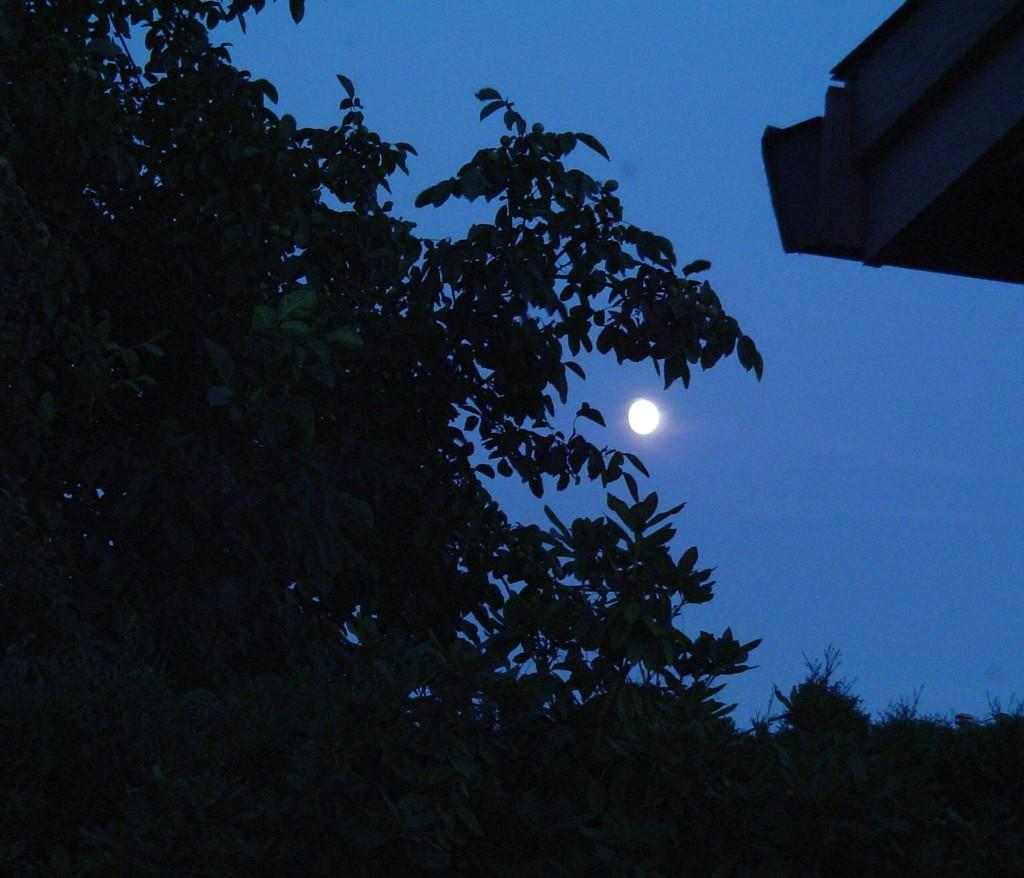What type of vegetation can be seen in the image? There are trees in the image. What is the color of the trees? The trees are green in color. What else is visible in the image besides the trees? The sky is visible in the image. What is the color of the sky? The sky is blue in color. Is there any celestial body visible in the image? Yes, there is a moon in the image. What is the color of the moon? The moon is white in color. What type of music can be heard playing in the image? There is no music present in the image, as it is a still image of trees, sky, and the moon. 